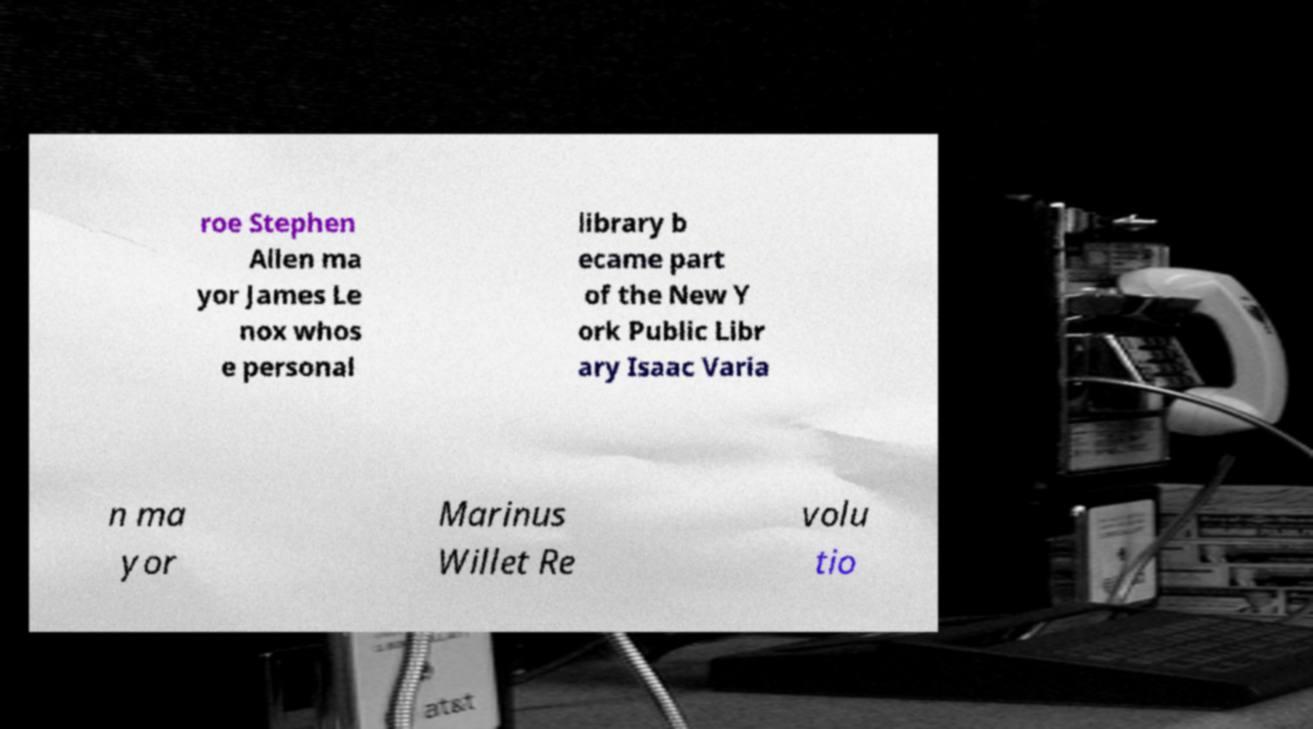For documentation purposes, I need the text within this image transcribed. Could you provide that? roe Stephen Allen ma yor James Le nox whos e personal library b ecame part of the New Y ork Public Libr ary Isaac Varia n ma yor Marinus Willet Re volu tio 